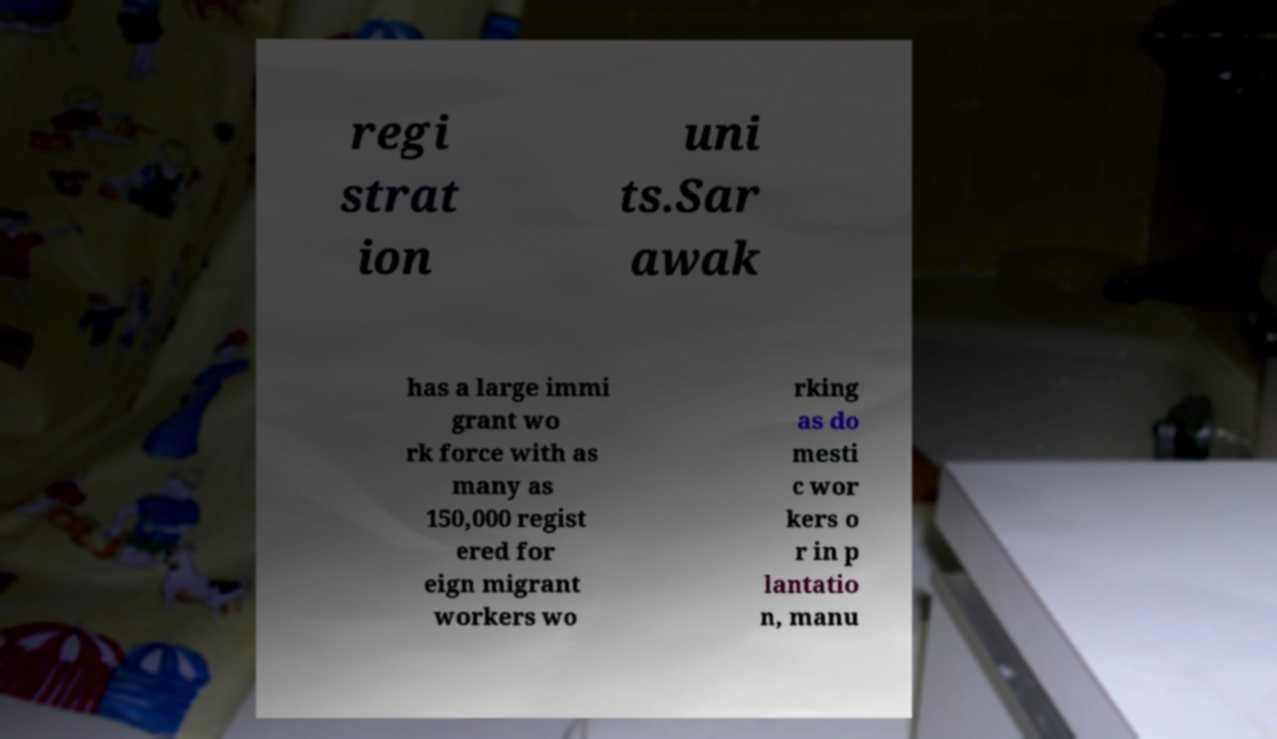Can you read and provide the text displayed in the image?This photo seems to have some interesting text. Can you extract and type it out for me? regi strat ion uni ts.Sar awak has a large immi grant wo rk force with as many as 150,000 regist ered for eign migrant workers wo rking as do mesti c wor kers o r in p lantatio n, manu 